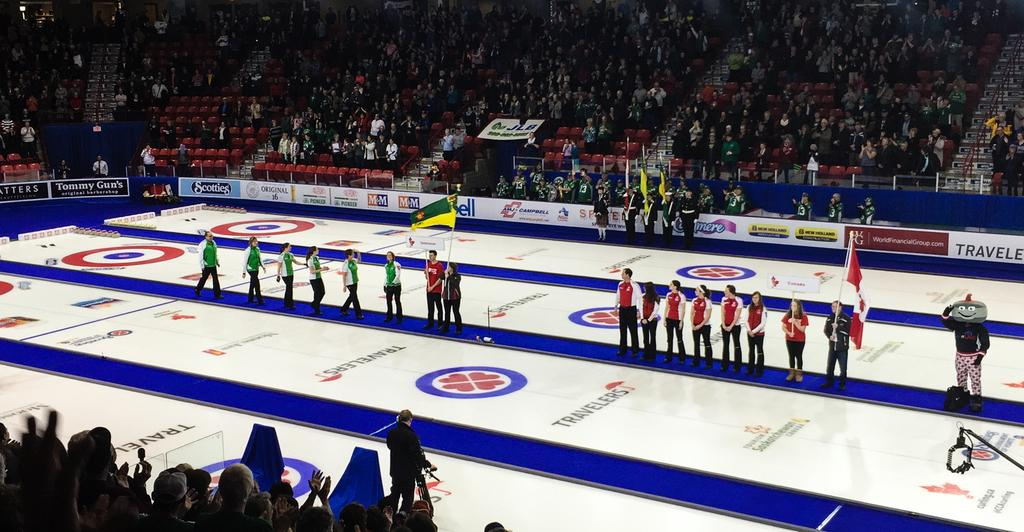Provide a one-sentence caption for the provided image. people lined up inside of an arena with a travelers logo on the ground. 